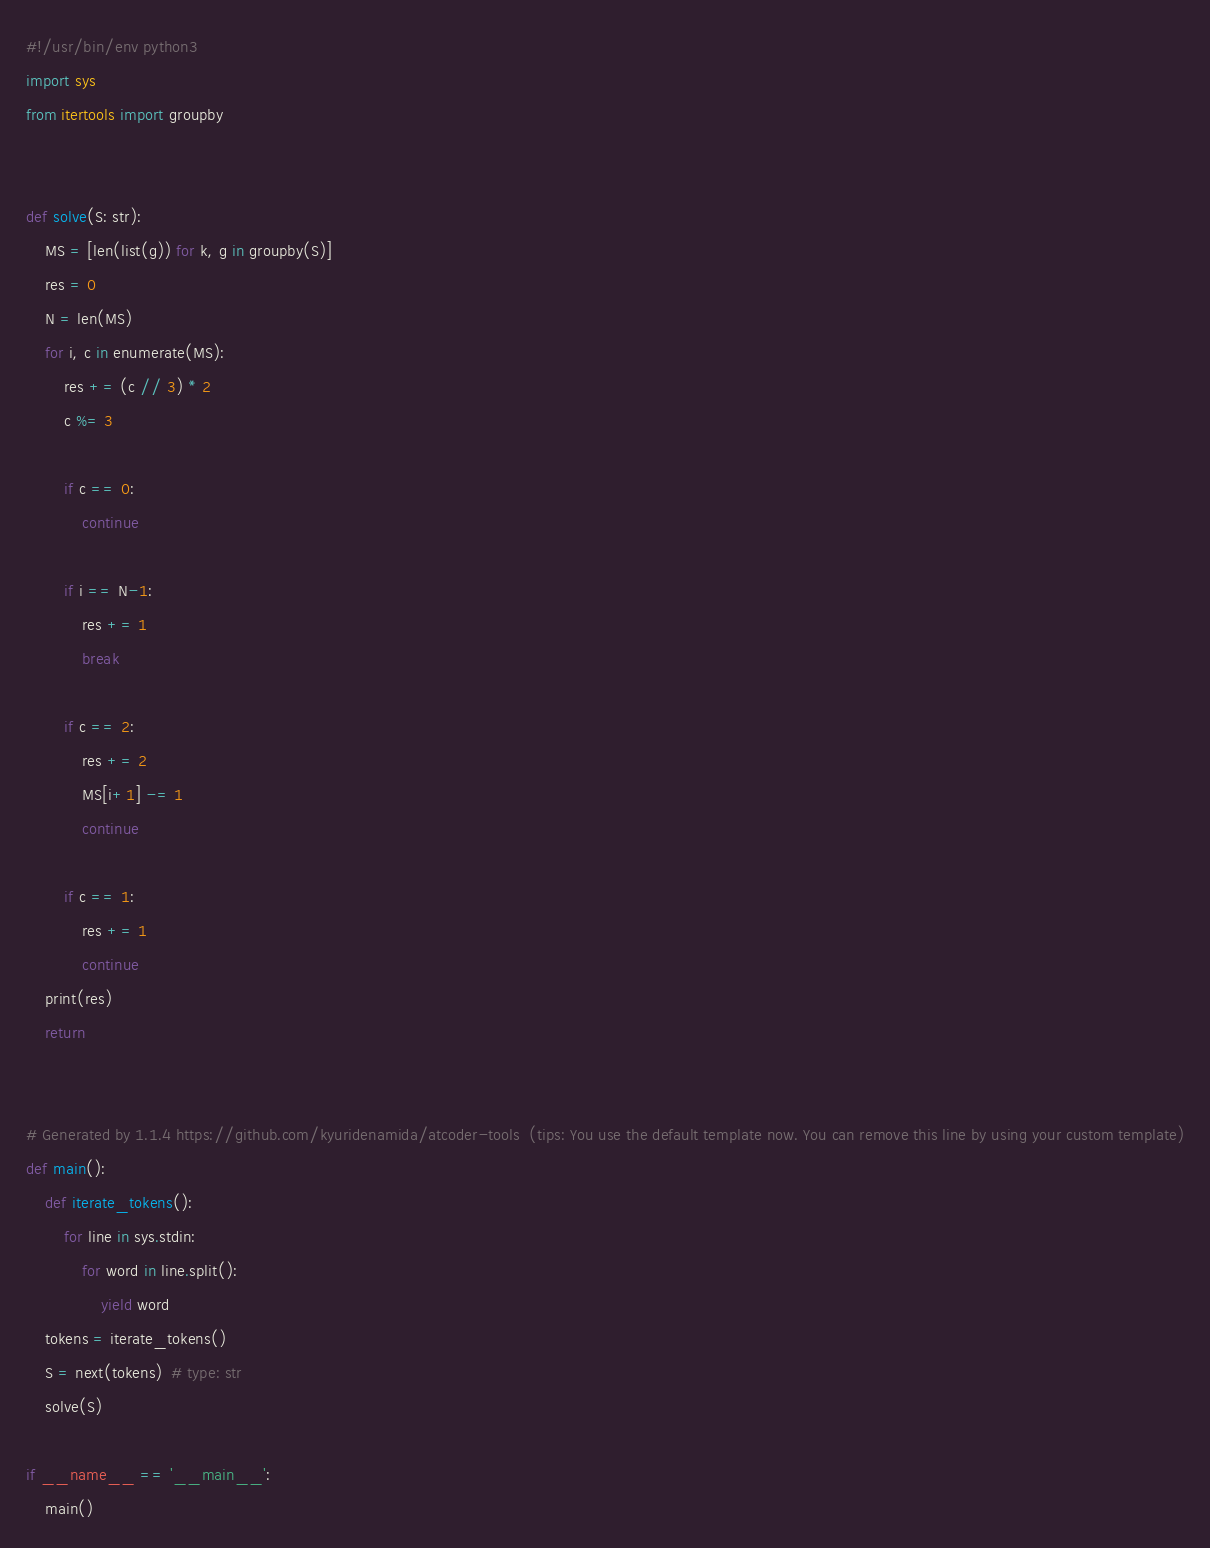<code> <loc_0><loc_0><loc_500><loc_500><_Python_>#!/usr/bin/env python3
import sys
from itertools import groupby


def solve(S: str):
    MS = [len(list(g)) for k, g in groupby(S)]
    res = 0
    N = len(MS)
    for i, c in enumerate(MS):
        res += (c // 3) * 2
        c %= 3

        if c == 0:
            continue

        if i == N-1:
            res += 1
            break

        if c == 2:
            res += 2
            MS[i+1] -= 1
            continue

        if c == 1:
            res += 1
            continue
    print(res)
    return


# Generated by 1.1.4 https://github.com/kyuridenamida/atcoder-tools  (tips: You use the default template now. You can remove this line by using your custom template)
def main():
    def iterate_tokens():
        for line in sys.stdin:
            for word in line.split():
                yield word
    tokens = iterate_tokens()
    S = next(tokens)  # type: str
    solve(S)

if __name__ == '__main__':
    main()
</code> 